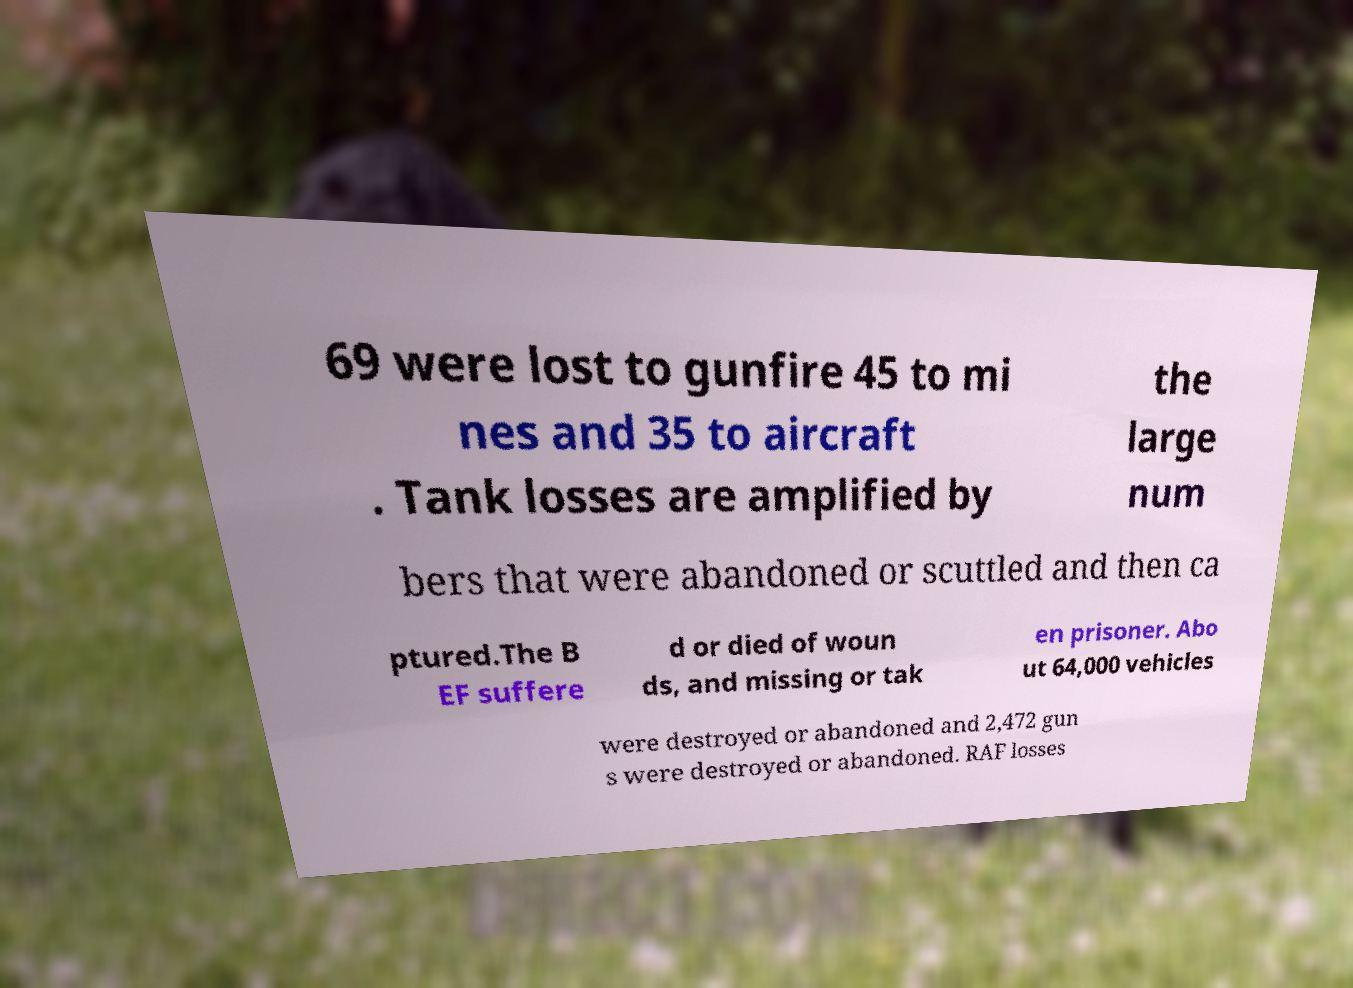Could you extract and type out the text from this image? 69 were lost to gunfire 45 to mi nes and 35 to aircraft . Tank losses are amplified by the large num bers that were abandoned or scuttled and then ca ptured.The B EF suffere d or died of woun ds, and missing or tak en prisoner. Abo ut 64,000 vehicles were destroyed or abandoned and 2,472 gun s were destroyed or abandoned. RAF losses 